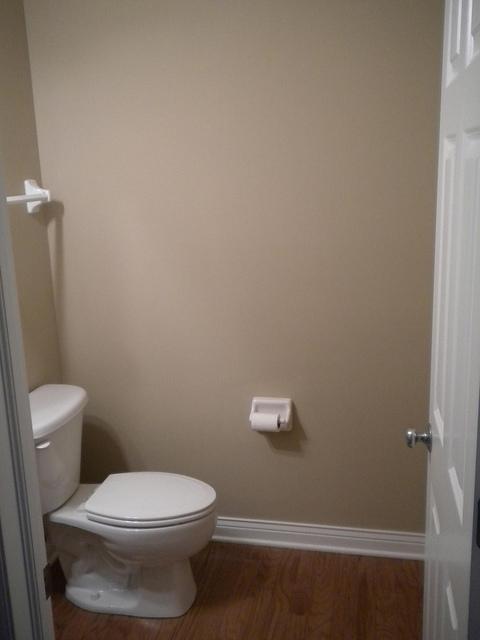How many boats are there?
Give a very brief answer. 0. 